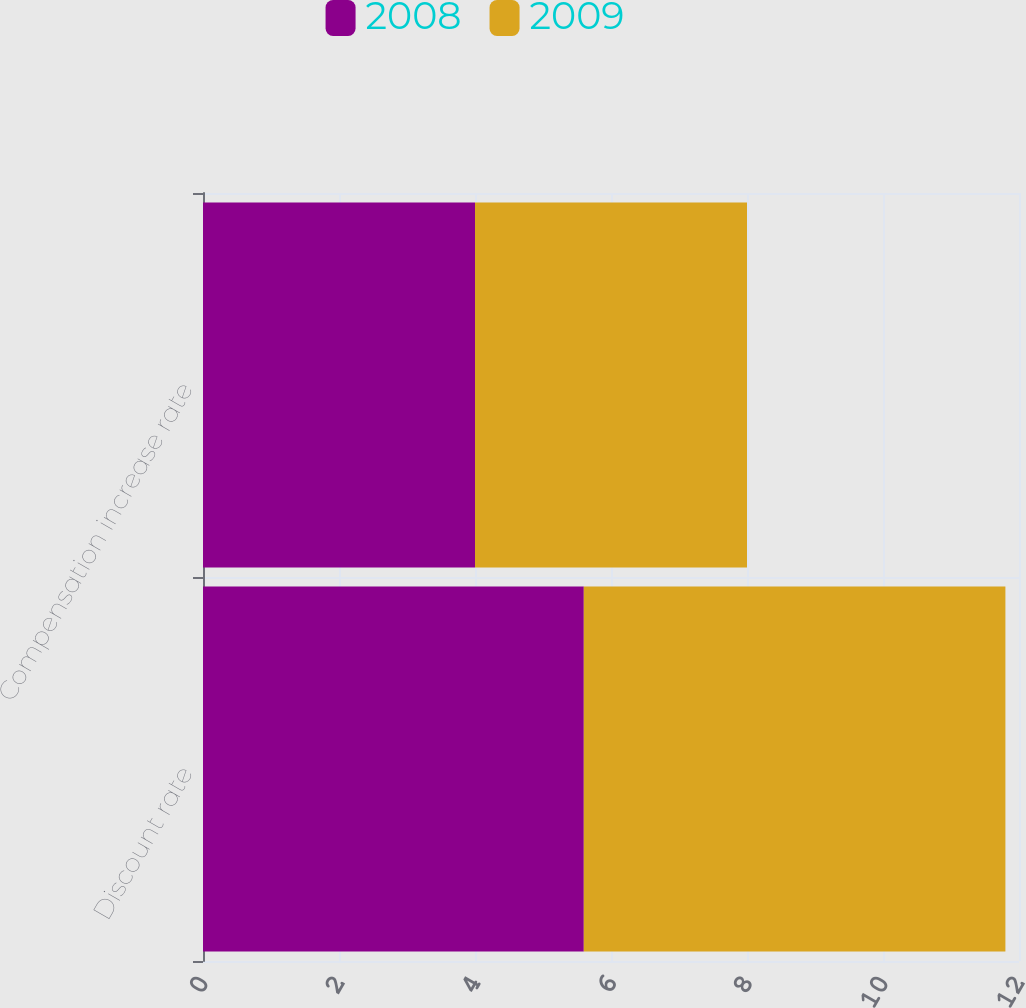<chart> <loc_0><loc_0><loc_500><loc_500><stacked_bar_chart><ecel><fcel>Discount rate<fcel>Compensation increase rate<nl><fcel>2008<fcel>5.6<fcel>4<nl><fcel>2009<fcel>6.2<fcel>4<nl></chart> 